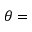<formula> <loc_0><loc_0><loc_500><loc_500>\theta =</formula> 